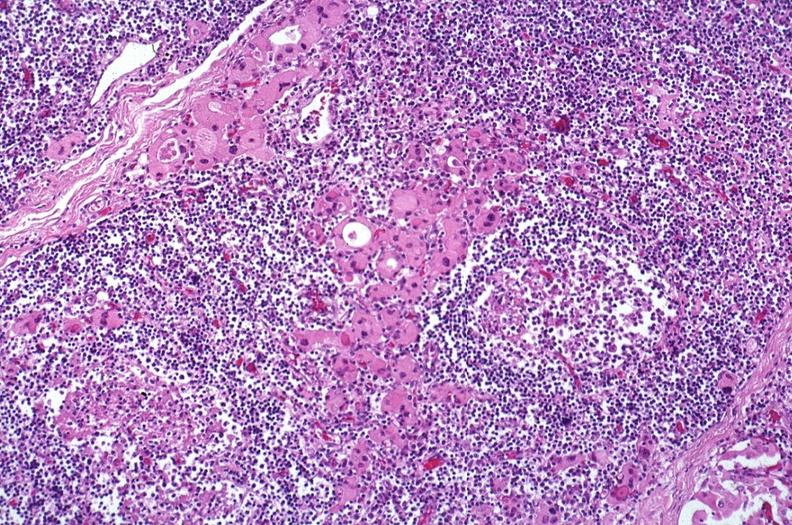s chest and abdomen slide present?
Answer the question using a single word or phrase. No 